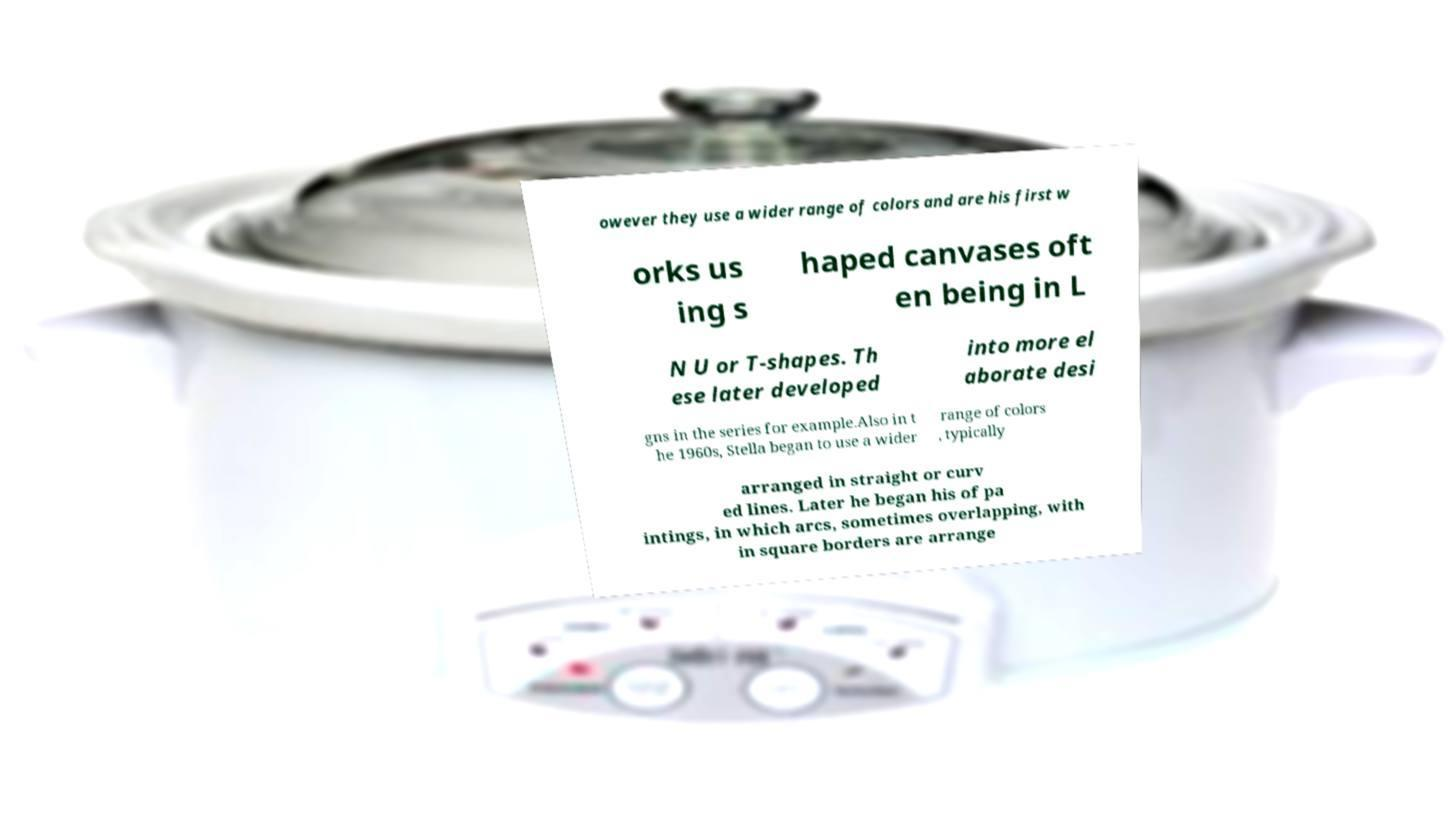There's text embedded in this image that I need extracted. Can you transcribe it verbatim? owever they use a wider range of colors and are his first w orks us ing s haped canvases oft en being in L N U or T-shapes. Th ese later developed into more el aborate desi gns in the series for example.Also in t he 1960s, Stella began to use a wider range of colors , typically arranged in straight or curv ed lines. Later he began his of pa intings, in which arcs, sometimes overlapping, with in square borders are arrange 